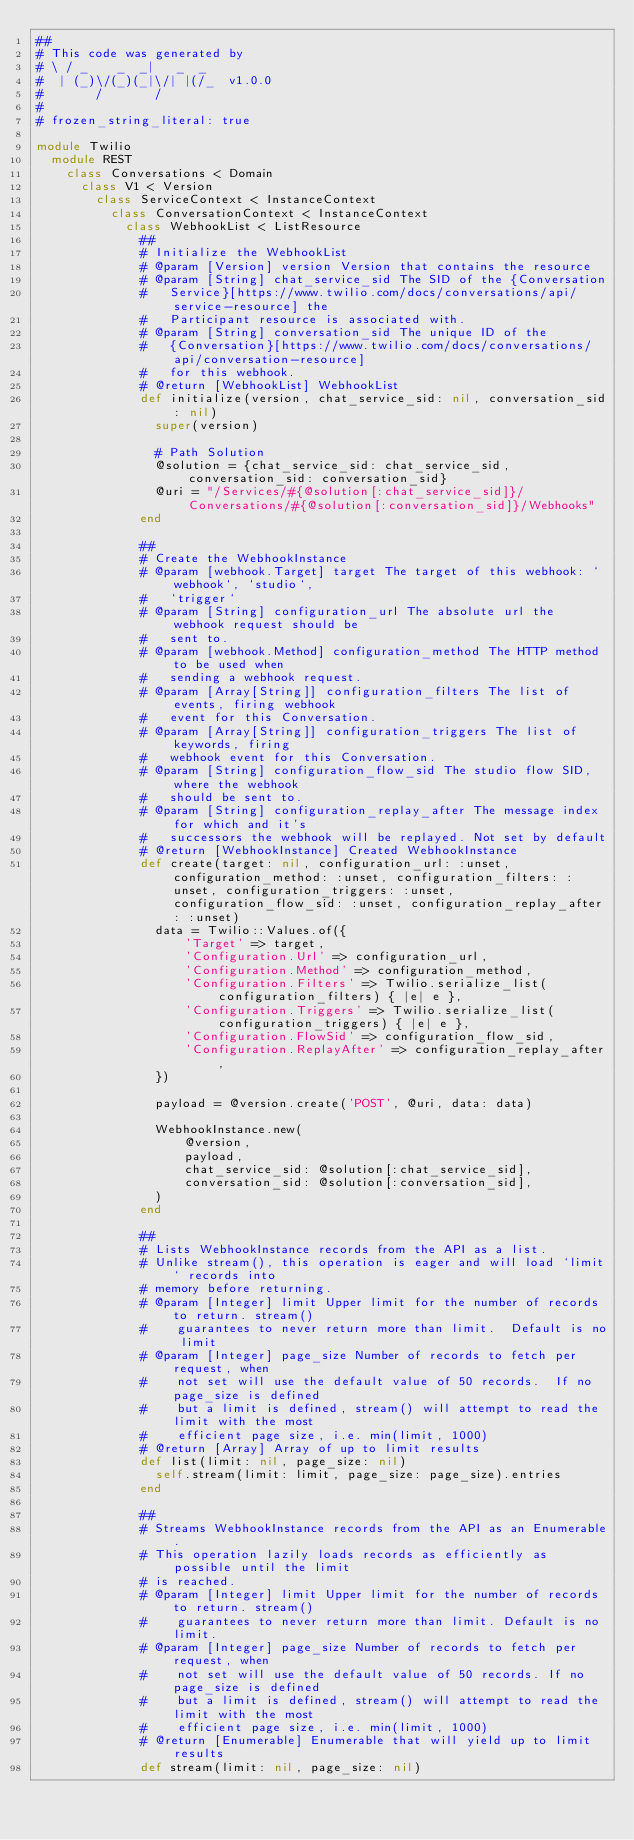<code> <loc_0><loc_0><loc_500><loc_500><_Ruby_>##
# This code was generated by
# \ / _    _  _|   _  _
#  | (_)\/(_)(_|\/| |(/_  v1.0.0
#       /       /
#
# frozen_string_literal: true

module Twilio
  module REST
    class Conversations < Domain
      class V1 < Version
        class ServiceContext < InstanceContext
          class ConversationContext < InstanceContext
            class WebhookList < ListResource
              ##
              # Initialize the WebhookList
              # @param [Version] version Version that contains the resource
              # @param [String] chat_service_sid The SID of the {Conversation
              #   Service}[https://www.twilio.com/docs/conversations/api/service-resource] the
              #   Participant resource is associated with.
              # @param [String] conversation_sid The unique ID of the
              #   {Conversation}[https://www.twilio.com/docs/conversations/api/conversation-resource]
              #   for this webhook.
              # @return [WebhookList] WebhookList
              def initialize(version, chat_service_sid: nil, conversation_sid: nil)
                super(version)

                # Path Solution
                @solution = {chat_service_sid: chat_service_sid, conversation_sid: conversation_sid}
                @uri = "/Services/#{@solution[:chat_service_sid]}/Conversations/#{@solution[:conversation_sid]}/Webhooks"
              end

              ##
              # Create the WebhookInstance
              # @param [webhook.Target] target The target of this webhook: `webhook`, `studio`,
              #   `trigger`
              # @param [String] configuration_url The absolute url the webhook request should be
              #   sent to.
              # @param [webhook.Method] configuration_method The HTTP method to be used when
              #   sending a webhook request.
              # @param [Array[String]] configuration_filters The list of events, firing webhook
              #   event for this Conversation.
              # @param [Array[String]] configuration_triggers The list of keywords, firing
              #   webhook event for this Conversation.
              # @param [String] configuration_flow_sid The studio flow SID, where the webhook
              #   should be sent to.
              # @param [String] configuration_replay_after The message index for which and it's
              #   successors the webhook will be replayed. Not set by default
              # @return [WebhookInstance] Created WebhookInstance
              def create(target: nil, configuration_url: :unset, configuration_method: :unset, configuration_filters: :unset, configuration_triggers: :unset, configuration_flow_sid: :unset, configuration_replay_after: :unset)
                data = Twilio::Values.of({
                    'Target' => target,
                    'Configuration.Url' => configuration_url,
                    'Configuration.Method' => configuration_method,
                    'Configuration.Filters' => Twilio.serialize_list(configuration_filters) { |e| e },
                    'Configuration.Triggers' => Twilio.serialize_list(configuration_triggers) { |e| e },
                    'Configuration.FlowSid' => configuration_flow_sid,
                    'Configuration.ReplayAfter' => configuration_replay_after,
                })

                payload = @version.create('POST', @uri, data: data)

                WebhookInstance.new(
                    @version,
                    payload,
                    chat_service_sid: @solution[:chat_service_sid],
                    conversation_sid: @solution[:conversation_sid],
                )
              end

              ##
              # Lists WebhookInstance records from the API as a list.
              # Unlike stream(), this operation is eager and will load `limit` records into
              # memory before returning.
              # @param [Integer] limit Upper limit for the number of records to return. stream()
              #    guarantees to never return more than limit.  Default is no limit
              # @param [Integer] page_size Number of records to fetch per request, when
              #    not set will use the default value of 50 records.  If no page_size is defined
              #    but a limit is defined, stream() will attempt to read the limit with the most
              #    efficient page size, i.e. min(limit, 1000)
              # @return [Array] Array of up to limit results
              def list(limit: nil, page_size: nil)
                self.stream(limit: limit, page_size: page_size).entries
              end

              ##
              # Streams WebhookInstance records from the API as an Enumerable.
              # This operation lazily loads records as efficiently as possible until the limit
              # is reached.
              # @param [Integer] limit Upper limit for the number of records to return. stream()
              #    guarantees to never return more than limit. Default is no limit.
              # @param [Integer] page_size Number of records to fetch per request, when
              #    not set will use the default value of 50 records. If no page_size is defined
              #    but a limit is defined, stream() will attempt to read the limit with the most
              #    efficient page size, i.e. min(limit, 1000)
              # @return [Enumerable] Enumerable that will yield up to limit results
              def stream(limit: nil, page_size: nil)</code> 